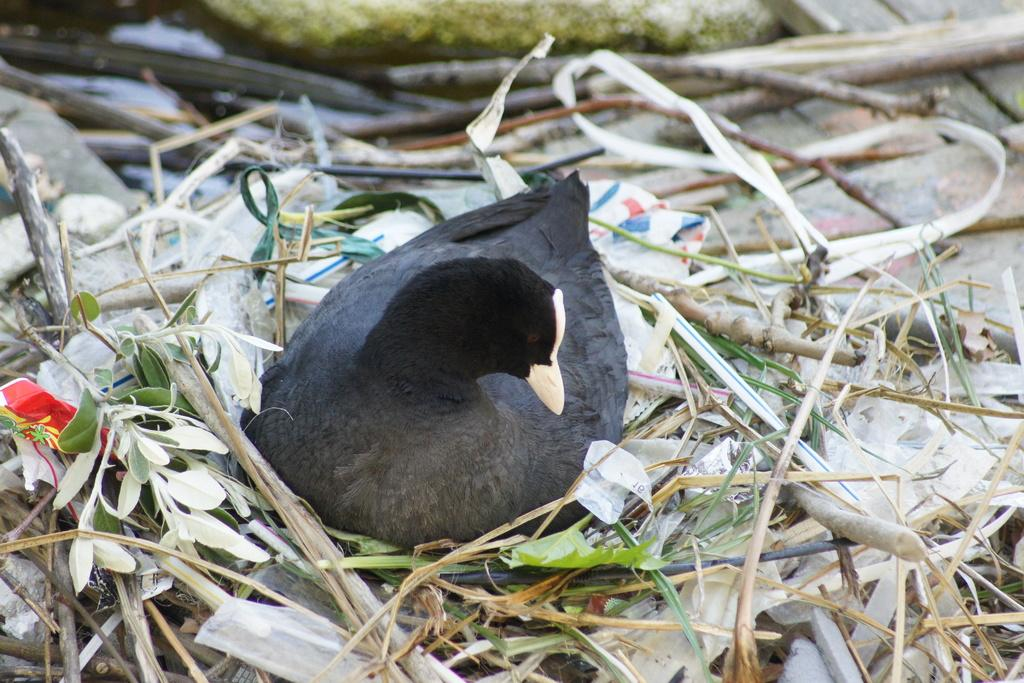What type of animal can be seen in the image? There is a bird in the image. What type of vegetation is present in the image? There is grass and leaves in the image. What objects can be seen in the image that are used for drinking? There are straws in the image. What other unspecified objects can be seen in the image? There are unspecified objects in the image. What type of coastline can be seen in the image? There is no coastline present in the image; it features a bird, grass, leaves, straws, and unspecified objects. What type of hands are visible in the image? There are no hands visible in the image. 